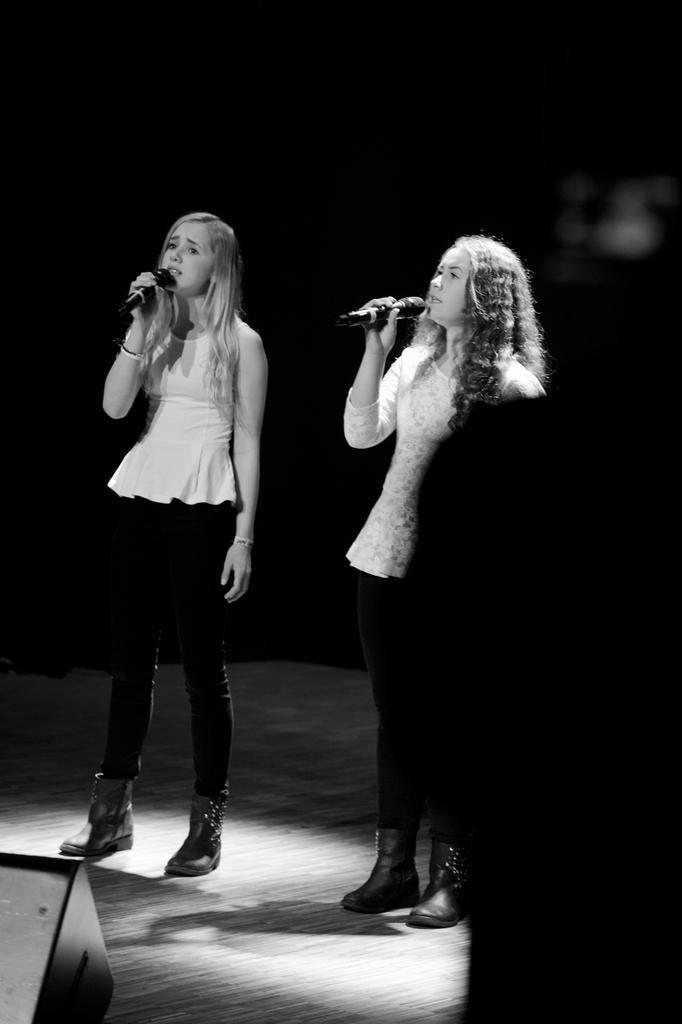How would you summarize this image in a sentence or two? In this image I can see two women are standing and I can see both of them are holding mics. I can also see this image is black and white in colour. 